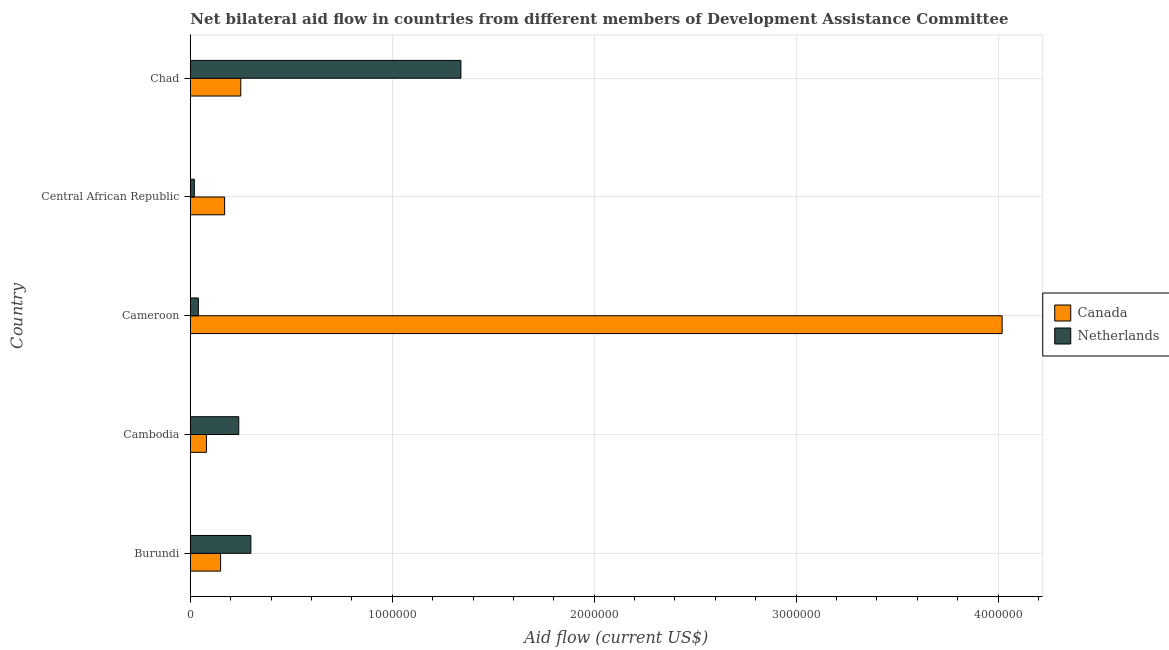How many different coloured bars are there?
Make the answer very short. 2. How many groups of bars are there?
Your response must be concise. 5. How many bars are there on the 4th tick from the bottom?
Ensure brevity in your answer.  2. What is the label of the 1st group of bars from the top?
Keep it short and to the point. Chad. What is the amount of aid given by canada in Central African Republic?
Provide a succinct answer. 1.70e+05. Across all countries, what is the maximum amount of aid given by netherlands?
Provide a short and direct response. 1.34e+06. Across all countries, what is the minimum amount of aid given by netherlands?
Ensure brevity in your answer.  2.00e+04. In which country was the amount of aid given by netherlands maximum?
Give a very brief answer. Chad. In which country was the amount of aid given by netherlands minimum?
Provide a short and direct response. Central African Republic. What is the total amount of aid given by netherlands in the graph?
Your answer should be compact. 1.94e+06. What is the difference between the amount of aid given by canada in Cambodia and that in Chad?
Offer a terse response. -1.70e+05. What is the difference between the amount of aid given by canada in Cameroon and the amount of aid given by netherlands in Central African Republic?
Your answer should be very brief. 4.00e+06. What is the average amount of aid given by netherlands per country?
Ensure brevity in your answer.  3.88e+05. What is the difference between the amount of aid given by netherlands and amount of aid given by canada in Burundi?
Keep it short and to the point. 1.50e+05. Is the difference between the amount of aid given by canada in Cameroon and Chad greater than the difference between the amount of aid given by netherlands in Cameroon and Chad?
Your answer should be compact. Yes. What is the difference between the highest and the second highest amount of aid given by netherlands?
Make the answer very short. 1.04e+06. What is the difference between the highest and the lowest amount of aid given by netherlands?
Your answer should be compact. 1.32e+06. In how many countries, is the amount of aid given by canada greater than the average amount of aid given by canada taken over all countries?
Make the answer very short. 1. Is the sum of the amount of aid given by canada in Burundi and Central African Republic greater than the maximum amount of aid given by netherlands across all countries?
Your answer should be very brief. No. How many bars are there?
Keep it short and to the point. 10. Are all the bars in the graph horizontal?
Make the answer very short. Yes. What is the difference between two consecutive major ticks on the X-axis?
Give a very brief answer. 1.00e+06. Are the values on the major ticks of X-axis written in scientific E-notation?
Offer a terse response. No. How many legend labels are there?
Your answer should be compact. 2. How are the legend labels stacked?
Your answer should be compact. Vertical. What is the title of the graph?
Your answer should be very brief. Net bilateral aid flow in countries from different members of Development Assistance Committee. What is the label or title of the Y-axis?
Your response must be concise. Country. What is the Aid flow (current US$) of Netherlands in Cambodia?
Provide a succinct answer. 2.40e+05. What is the Aid flow (current US$) of Canada in Cameroon?
Your response must be concise. 4.02e+06. What is the Aid flow (current US$) of Canada in Chad?
Your answer should be very brief. 2.50e+05. What is the Aid flow (current US$) in Netherlands in Chad?
Your answer should be compact. 1.34e+06. Across all countries, what is the maximum Aid flow (current US$) in Canada?
Give a very brief answer. 4.02e+06. Across all countries, what is the maximum Aid flow (current US$) in Netherlands?
Provide a succinct answer. 1.34e+06. Across all countries, what is the minimum Aid flow (current US$) in Canada?
Keep it short and to the point. 8.00e+04. Across all countries, what is the minimum Aid flow (current US$) in Netherlands?
Ensure brevity in your answer.  2.00e+04. What is the total Aid flow (current US$) of Canada in the graph?
Offer a terse response. 4.67e+06. What is the total Aid flow (current US$) in Netherlands in the graph?
Give a very brief answer. 1.94e+06. What is the difference between the Aid flow (current US$) in Netherlands in Burundi and that in Cambodia?
Ensure brevity in your answer.  6.00e+04. What is the difference between the Aid flow (current US$) of Canada in Burundi and that in Cameroon?
Your answer should be very brief. -3.87e+06. What is the difference between the Aid flow (current US$) in Canada in Burundi and that in Central African Republic?
Make the answer very short. -2.00e+04. What is the difference between the Aid flow (current US$) in Netherlands in Burundi and that in Central African Republic?
Make the answer very short. 2.80e+05. What is the difference between the Aid flow (current US$) of Canada in Burundi and that in Chad?
Offer a very short reply. -1.00e+05. What is the difference between the Aid flow (current US$) in Netherlands in Burundi and that in Chad?
Provide a succinct answer. -1.04e+06. What is the difference between the Aid flow (current US$) of Canada in Cambodia and that in Cameroon?
Your answer should be very brief. -3.94e+06. What is the difference between the Aid flow (current US$) in Netherlands in Cambodia and that in Central African Republic?
Keep it short and to the point. 2.20e+05. What is the difference between the Aid flow (current US$) in Canada in Cambodia and that in Chad?
Provide a succinct answer. -1.70e+05. What is the difference between the Aid flow (current US$) in Netherlands in Cambodia and that in Chad?
Keep it short and to the point. -1.10e+06. What is the difference between the Aid flow (current US$) of Canada in Cameroon and that in Central African Republic?
Offer a very short reply. 3.85e+06. What is the difference between the Aid flow (current US$) of Canada in Cameroon and that in Chad?
Provide a succinct answer. 3.77e+06. What is the difference between the Aid flow (current US$) of Netherlands in Cameroon and that in Chad?
Your response must be concise. -1.30e+06. What is the difference between the Aid flow (current US$) in Canada in Central African Republic and that in Chad?
Provide a succinct answer. -8.00e+04. What is the difference between the Aid flow (current US$) in Netherlands in Central African Republic and that in Chad?
Ensure brevity in your answer.  -1.32e+06. What is the difference between the Aid flow (current US$) of Canada in Burundi and the Aid flow (current US$) of Netherlands in Chad?
Offer a very short reply. -1.19e+06. What is the difference between the Aid flow (current US$) in Canada in Cambodia and the Aid flow (current US$) in Netherlands in Chad?
Your answer should be compact. -1.26e+06. What is the difference between the Aid flow (current US$) in Canada in Cameroon and the Aid flow (current US$) in Netherlands in Central African Republic?
Offer a very short reply. 4.00e+06. What is the difference between the Aid flow (current US$) in Canada in Cameroon and the Aid flow (current US$) in Netherlands in Chad?
Keep it short and to the point. 2.68e+06. What is the difference between the Aid flow (current US$) in Canada in Central African Republic and the Aid flow (current US$) in Netherlands in Chad?
Your answer should be very brief. -1.17e+06. What is the average Aid flow (current US$) of Canada per country?
Offer a terse response. 9.34e+05. What is the average Aid flow (current US$) in Netherlands per country?
Provide a short and direct response. 3.88e+05. What is the difference between the Aid flow (current US$) in Canada and Aid flow (current US$) in Netherlands in Cameroon?
Give a very brief answer. 3.98e+06. What is the difference between the Aid flow (current US$) of Canada and Aid flow (current US$) of Netherlands in Central African Republic?
Keep it short and to the point. 1.50e+05. What is the difference between the Aid flow (current US$) in Canada and Aid flow (current US$) in Netherlands in Chad?
Ensure brevity in your answer.  -1.09e+06. What is the ratio of the Aid flow (current US$) of Canada in Burundi to that in Cambodia?
Your answer should be very brief. 1.88. What is the ratio of the Aid flow (current US$) of Netherlands in Burundi to that in Cambodia?
Your response must be concise. 1.25. What is the ratio of the Aid flow (current US$) in Canada in Burundi to that in Cameroon?
Give a very brief answer. 0.04. What is the ratio of the Aid flow (current US$) in Canada in Burundi to that in Central African Republic?
Offer a terse response. 0.88. What is the ratio of the Aid flow (current US$) of Canada in Burundi to that in Chad?
Give a very brief answer. 0.6. What is the ratio of the Aid flow (current US$) in Netherlands in Burundi to that in Chad?
Offer a terse response. 0.22. What is the ratio of the Aid flow (current US$) in Canada in Cambodia to that in Cameroon?
Your answer should be very brief. 0.02. What is the ratio of the Aid flow (current US$) in Canada in Cambodia to that in Central African Republic?
Provide a short and direct response. 0.47. What is the ratio of the Aid flow (current US$) of Netherlands in Cambodia to that in Central African Republic?
Keep it short and to the point. 12. What is the ratio of the Aid flow (current US$) of Canada in Cambodia to that in Chad?
Your response must be concise. 0.32. What is the ratio of the Aid flow (current US$) of Netherlands in Cambodia to that in Chad?
Provide a short and direct response. 0.18. What is the ratio of the Aid flow (current US$) in Canada in Cameroon to that in Central African Republic?
Keep it short and to the point. 23.65. What is the ratio of the Aid flow (current US$) in Canada in Cameroon to that in Chad?
Ensure brevity in your answer.  16.08. What is the ratio of the Aid flow (current US$) in Netherlands in Cameroon to that in Chad?
Offer a terse response. 0.03. What is the ratio of the Aid flow (current US$) in Canada in Central African Republic to that in Chad?
Provide a short and direct response. 0.68. What is the ratio of the Aid flow (current US$) of Netherlands in Central African Republic to that in Chad?
Offer a terse response. 0.01. What is the difference between the highest and the second highest Aid flow (current US$) of Canada?
Ensure brevity in your answer.  3.77e+06. What is the difference between the highest and the second highest Aid flow (current US$) in Netherlands?
Keep it short and to the point. 1.04e+06. What is the difference between the highest and the lowest Aid flow (current US$) of Canada?
Your response must be concise. 3.94e+06. What is the difference between the highest and the lowest Aid flow (current US$) in Netherlands?
Provide a short and direct response. 1.32e+06. 